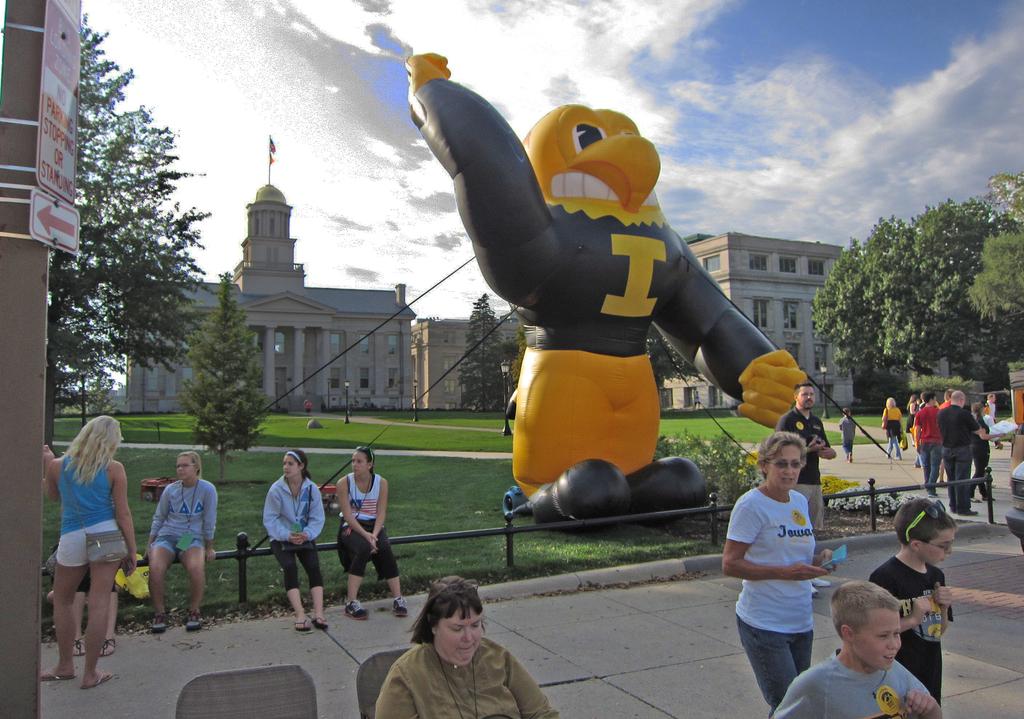What letter is on the bird's jacket?
Offer a terse response. I. What color is the letter i on the  bird's shirt?
Make the answer very short. Yellow. 